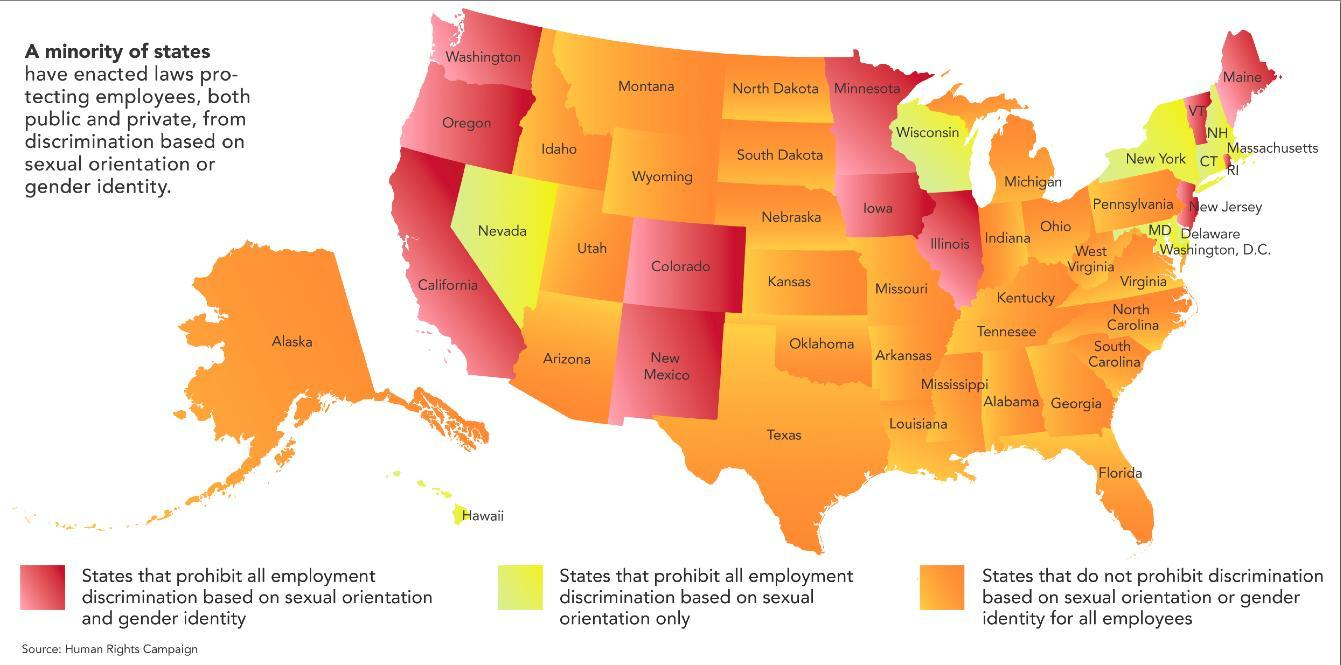what is the name of the state which is an island and coloured in orange in the info graphic?
Answer the question with a short phrase. Alaska what is the name of the state which is an island and coloured in yellow in the info graphic? Hawaii How many states have prohibited all discrimination based on sex, gender? 12 What is the color given to the states which have not prohibited discrimination either based on sex or gender- red, green, orange, yellow? orange What is the color given to the states which have prohibited discrimination based only on sex orientation- green, yellow, orange, red? yellow 